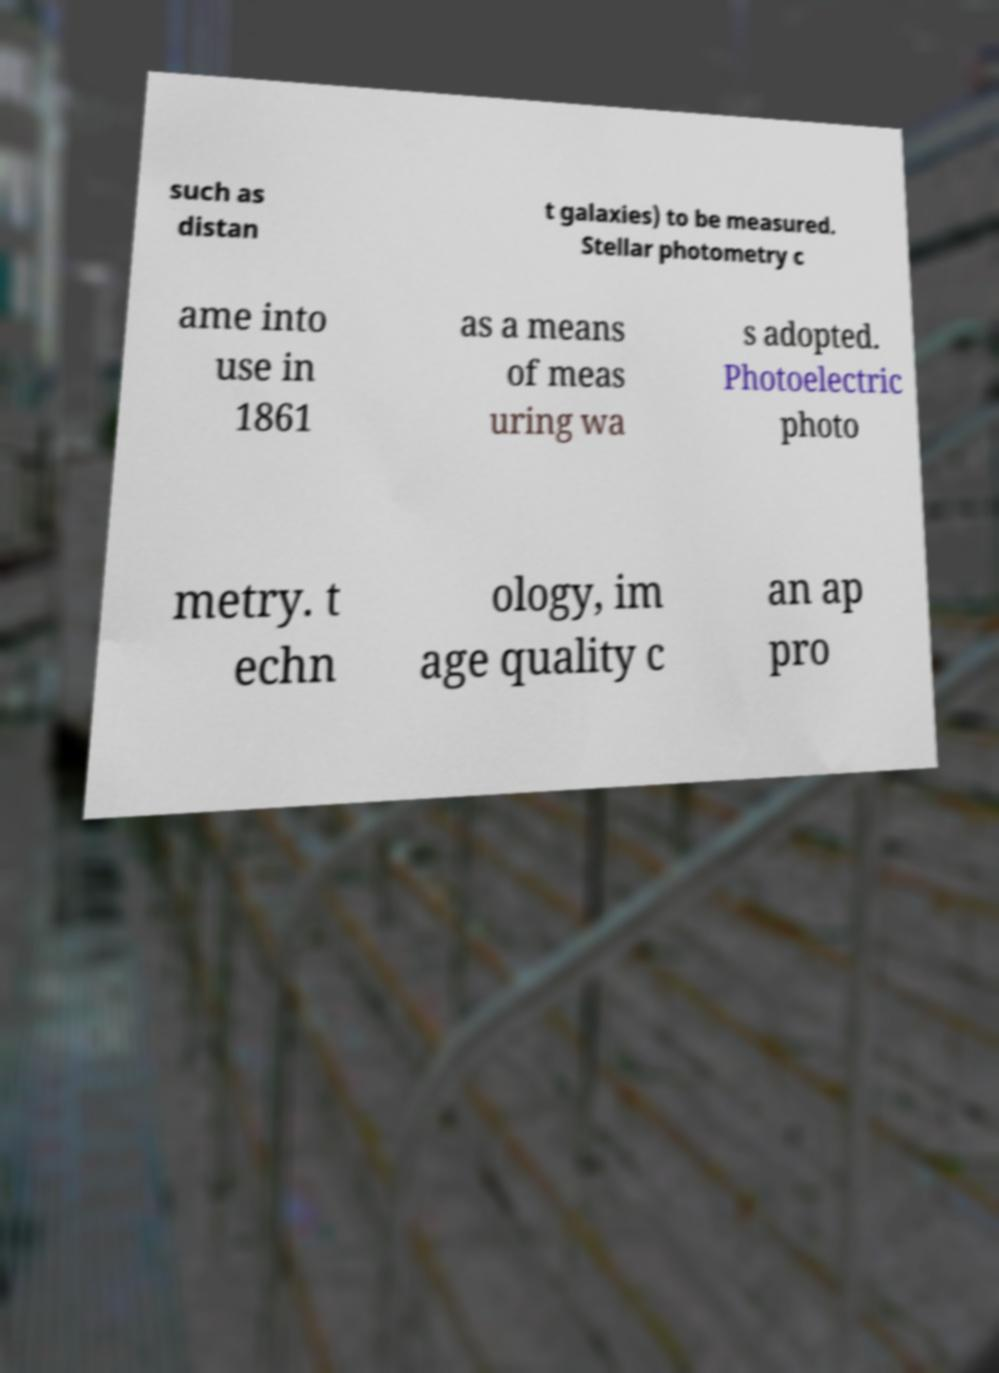What messages or text are displayed in this image? I need them in a readable, typed format. such as distan t galaxies) to be measured. Stellar photometry c ame into use in 1861 as a means of meas uring wa s adopted. Photoelectric photo metry. t echn ology, im age quality c an ap pro 